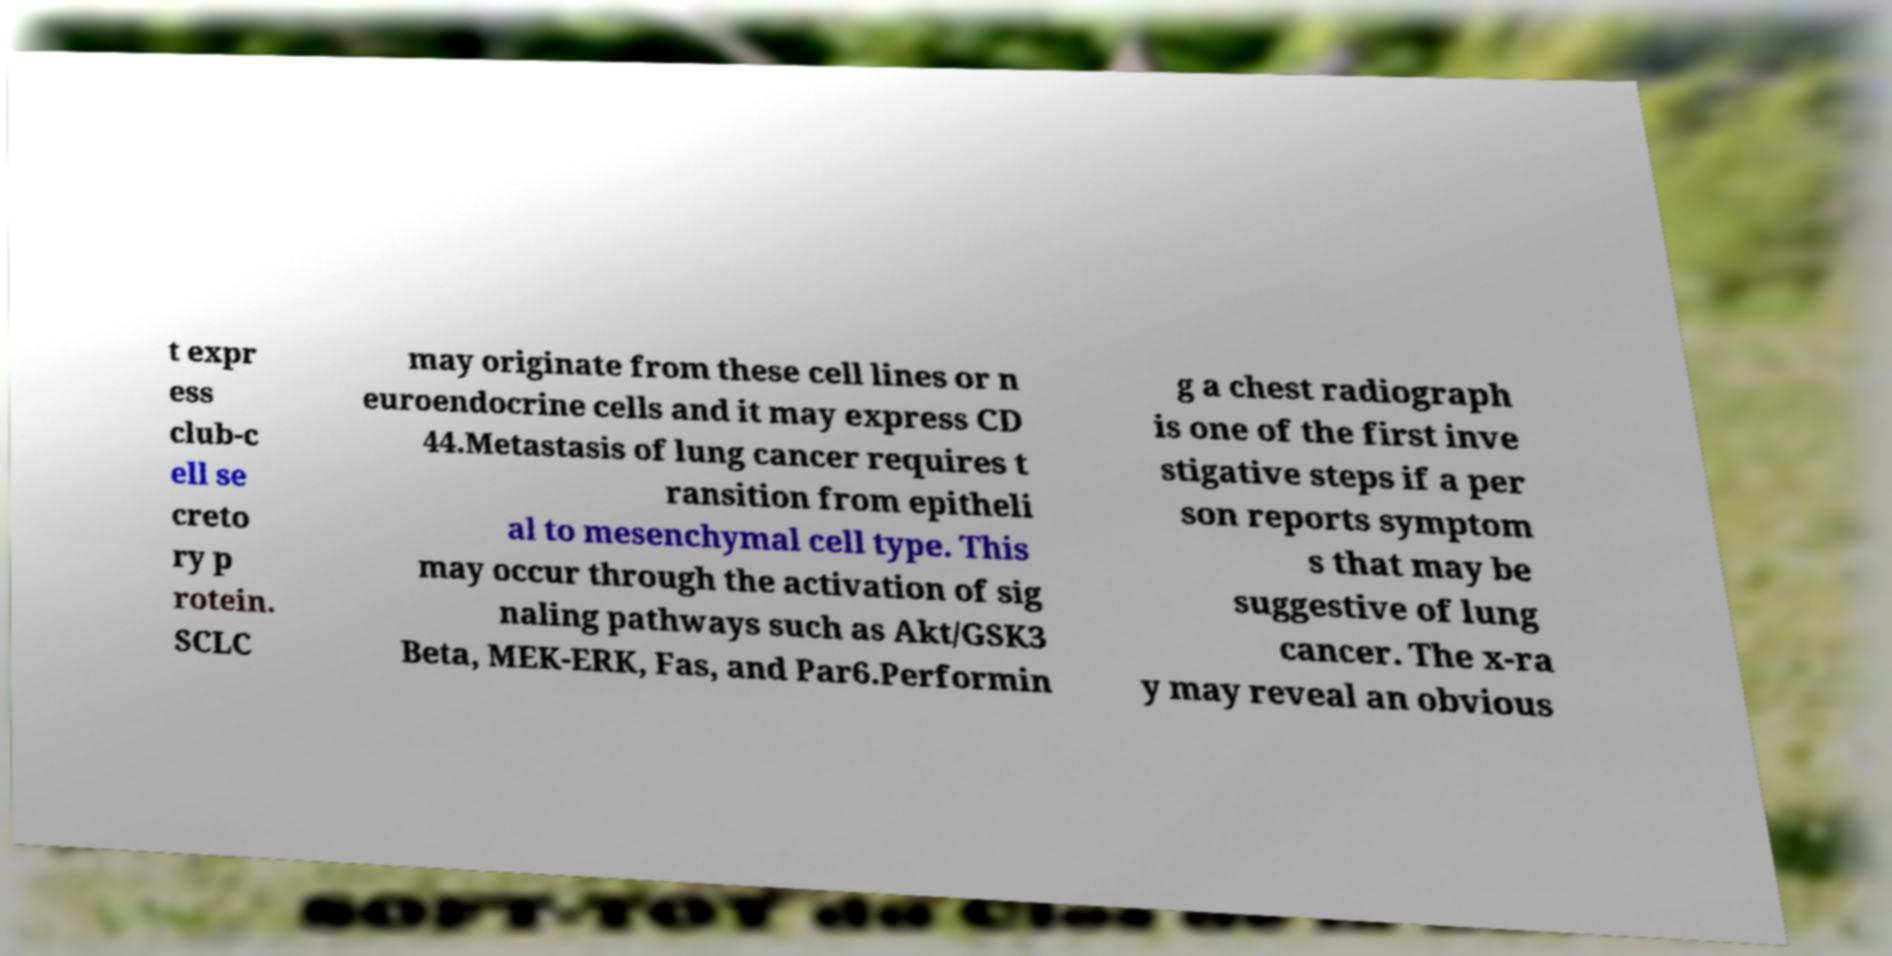Could you assist in decoding the text presented in this image and type it out clearly? t expr ess club-c ell se creto ry p rotein. SCLC may originate from these cell lines or n euroendocrine cells and it may express CD 44.Metastasis of lung cancer requires t ransition from epitheli al to mesenchymal cell type. This may occur through the activation of sig naling pathways such as Akt/GSK3 Beta, MEK-ERK, Fas, and Par6.Performin g a chest radiograph is one of the first inve stigative steps if a per son reports symptom s that may be suggestive of lung cancer. The x-ra y may reveal an obvious 